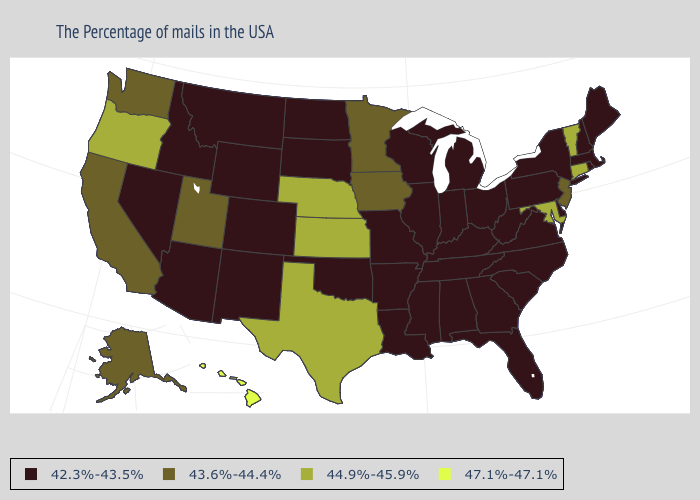Name the states that have a value in the range 42.3%-43.5%?
Give a very brief answer. Maine, Massachusetts, Rhode Island, New Hampshire, New York, Delaware, Pennsylvania, Virginia, North Carolina, South Carolina, West Virginia, Ohio, Florida, Georgia, Michigan, Kentucky, Indiana, Alabama, Tennessee, Wisconsin, Illinois, Mississippi, Louisiana, Missouri, Arkansas, Oklahoma, South Dakota, North Dakota, Wyoming, Colorado, New Mexico, Montana, Arizona, Idaho, Nevada. What is the value of California?
Concise answer only. 43.6%-44.4%. What is the highest value in the USA?
Short answer required. 47.1%-47.1%. Does the first symbol in the legend represent the smallest category?
Keep it brief. Yes. What is the lowest value in the USA?
Answer briefly. 42.3%-43.5%. Name the states that have a value in the range 42.3%-43.5%?
Give a very brief answer. Maine, Massachusetts, Rhode Island, New Hampshire, New York, Delaware, Pennsylvania, Virginia, North Carolina, South Carolina, West Virginia, Ohio, Florida, Georgia, Michigan, Kentucky, Indiana, Alabama, Tennessee, Wisconsin, Illinois, Mississippi, Louisiana, Missouri, Arkansas, Oklahoma, South Dakota, North Dakota, Wyoming, Colorado, New Mexico, Montana, Arizona, Idaho, Nevada. Does Hawaii have the highest value in the USA?
Be succinct. Yes. Which states have the highest value in the USA?
Keep it brief. Hawaii. Name the states that have a value in the range 43.6%-44.4%?
Write a very short answer. New Jersey, Minnesota, Iowa, Utah, California, Washington, Alaska. Which states hav the highest value in the Northeast?
Concise answer only. Vermont, Connecticut. Is the legend a continuous bar?
Keep it brief. No. Does the map have missing data?
Concise answer only. No. Does Hawaii have the highest value in the USA?
Answer briefly. Yes. Name the states that have a value in the range 44.9%-45.9%?
Write a very short answer. Vermont, Connecticut, Maryland, Kansas, Nebraska, Texas, Oregon. Does Ohio have the highest value in the USA?
Write a very short answer. No. 